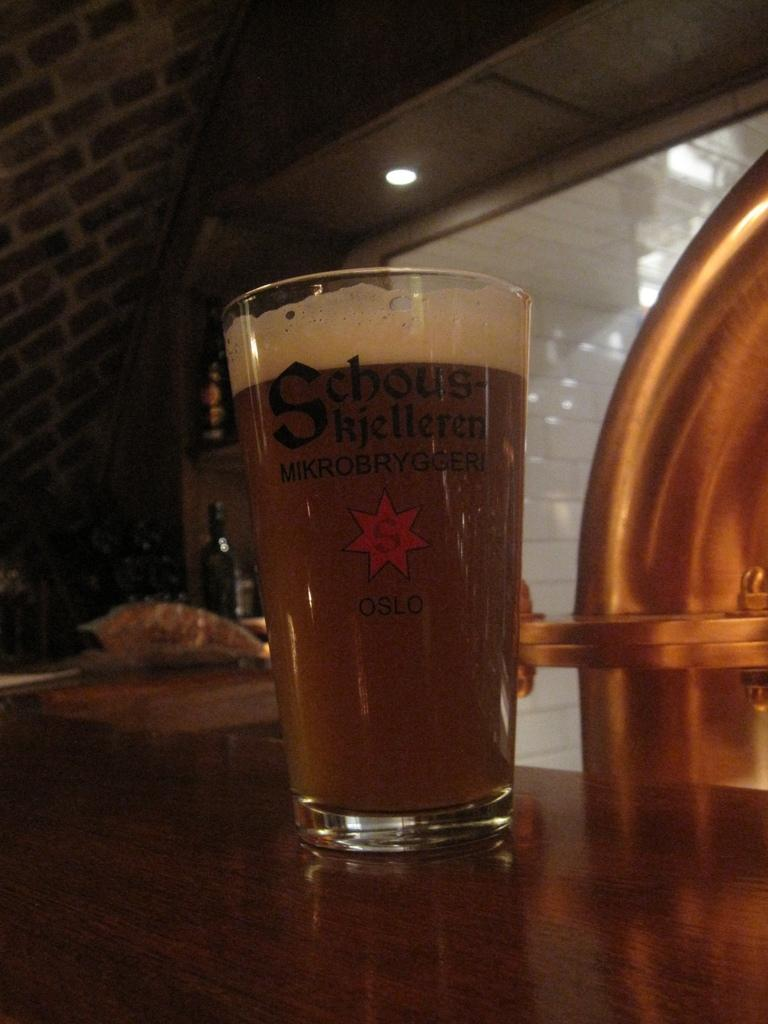<image>
Write a terse but informative summary of the picture. A glass full of liquid features the text Schouskjelleren Mikrobryggeri. 